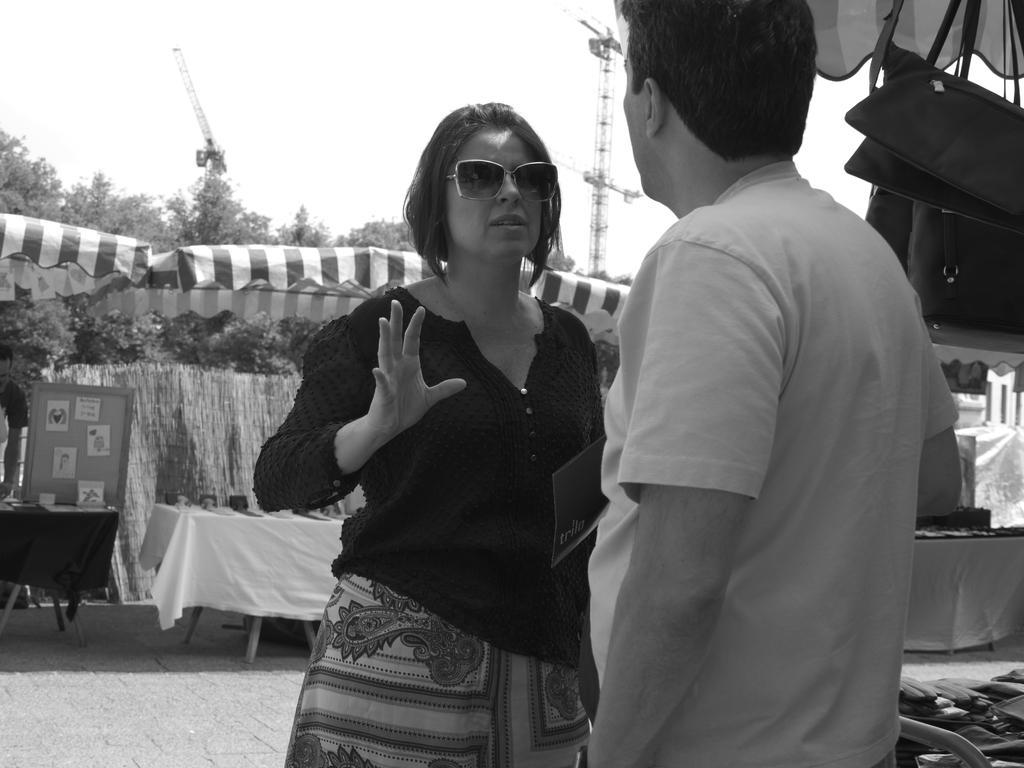Can you describe this image briefly? In the picture I can see a man and woman wearing black and white color dress respectively, woman also wearing goggles and in the background of the picture there are some tables on which there are some objects, there are some trees, tower, crane and clear sky. 